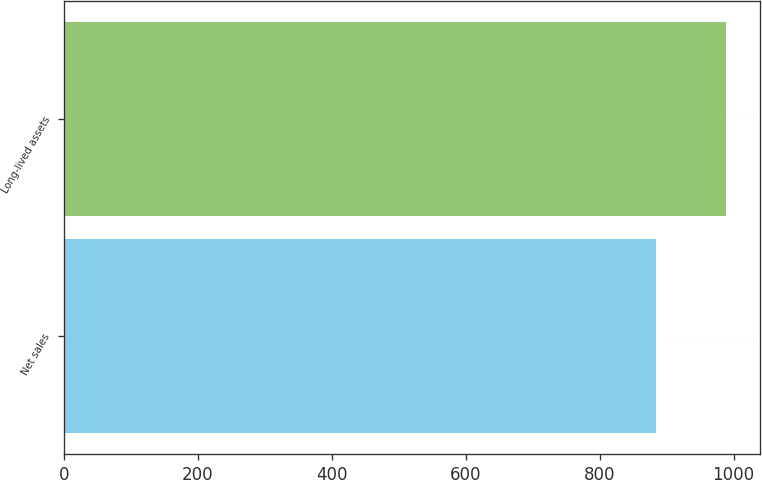Convert chart. <chart><loc_0><loc_0><loc_500><loc_500><bar_chart><fcel>Net sales<fcel>Long-lived assets<nl><fcel>883.4<fcel>989.2<nl></chart> 